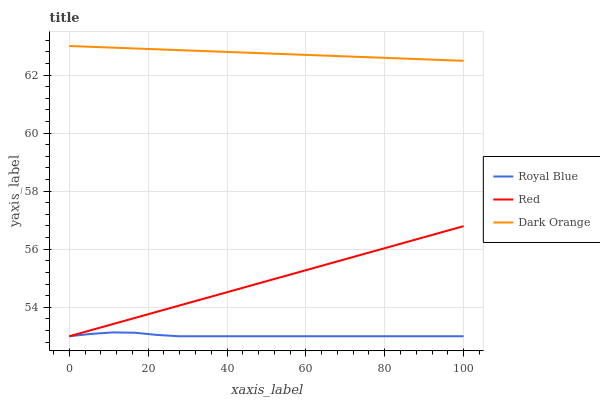Does Royal Blue have the minimum area under the curve?
Answer yes or no. Yes. Does Dark Orange have the maximum area under the curve?
Answer yes or no. Yes. Does Red have the minimum area under the curve?
Answer yes or no. No. Does Red have the maximum area under the curve?
Answer yes or no. No. Is Dark Orange the smoothest?
Answer yes or no. Yes. Is Royal Blue the roughest?
Answer yes or no. Yes. Is Red the smoothest?
Answer yes or no. No. Is Red the roughest?
Answer yes or no. No. Does Royal Blue have the lowest value?
Answer yes or no. Yes. Does Dark Orange have the lowest value?
Answer yes or no. No. Does Dark Orange have the highest value?
Answer yes or no. Yes. Does Red have the highest value?
Answer yes or no. No. Is Red less than Dark Orange?
Answer yes or no. Yes. Is Dark Orange greater than Red?
Answer yes or no. Yes. Does Red intersect Royal Blue?
Answer yes or no. Yes. Is Red less than Royal Blue?
Answer yes or no. No. Is Red greater than Royal Blue?
Answer yes or no. No. Does Red intersect Dark Orange?
Answer yes or no. No. 